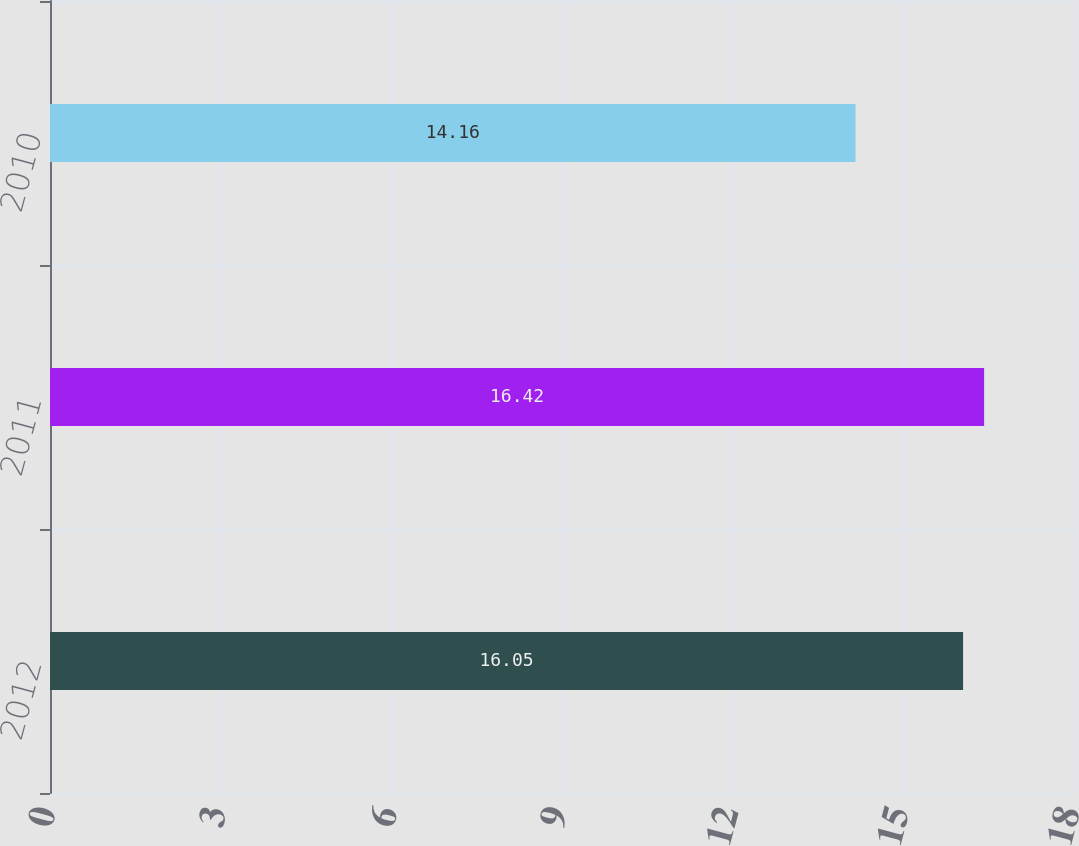Convert chart. <chart><loc_0><loc_0><loc_500><loc_500><bar_chart><fcel>2012<fcel>2011<fcel>2010<nl><fcel>16.05<fcel>16.42<fcel>14.16<nl></chart> 